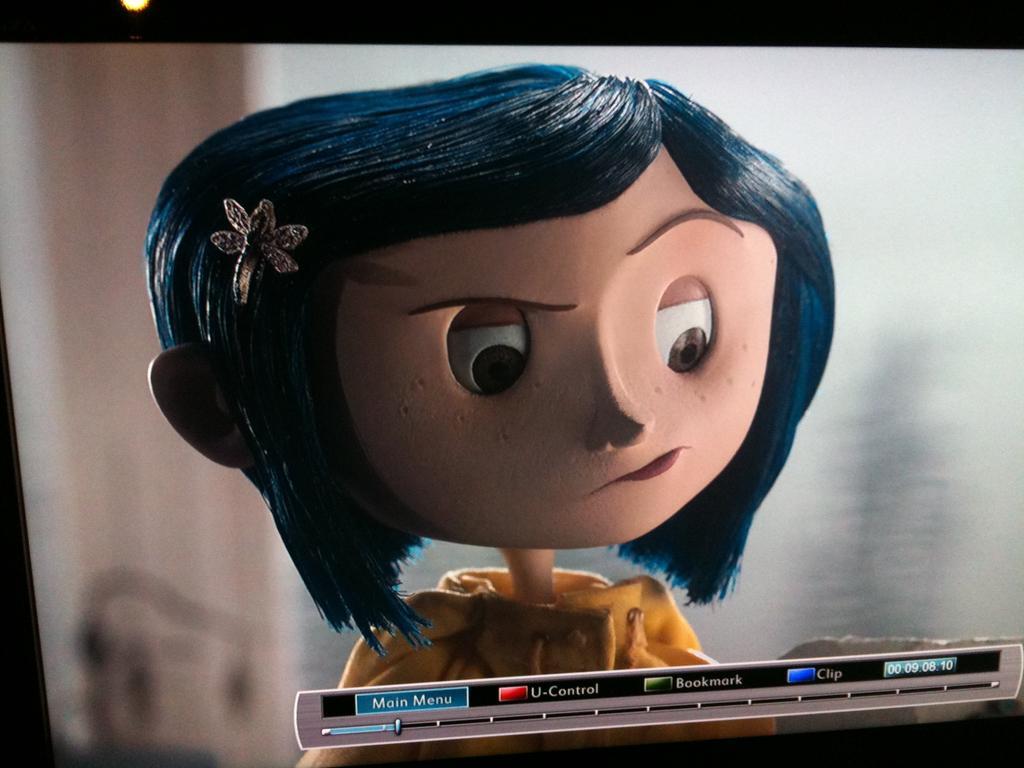Could you give a brief overview of what you see in this image? This is an animated image in which there is a cartoon image of the girl and there are some text written which are visible. 